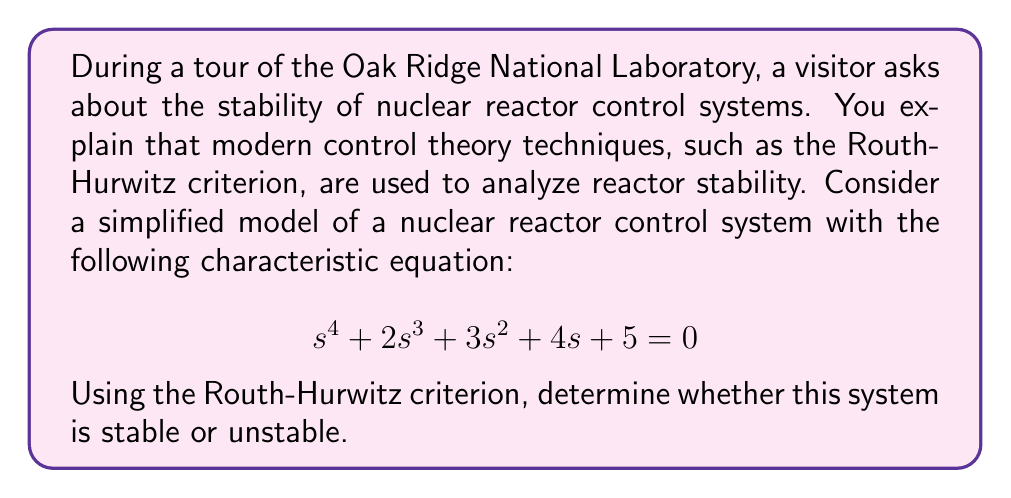Show me your answer to this math problem. To analyze the stability of the system using the Routh-Hurwitz criterion, we need to construct the Routh array and examine the signs of the coefficients in the first column.

Step 1: Construct the Routh array

The Routh array for the given characteristic equation is:

$$\begin{array}{c|cccc}
s^4 & 1 & 3 & 5 \\
s^3 & 2 & 4 & 0 \\
s^2 & b_1 & b_2 & \\
s^1 & c_1 & \\
s^0 & d_1 &
\end{array}$$

Step 2: Calculate the values for $b_1$, $b_2$, $c_1$, and $d_1$

$b_1 = \frac{(2)(3) - (1)(4)}{2} = \frac{6 - 4}{2} = 1$

$b_2 = \frac{(2)(5) - (1)(0)}{2} = \frac{10}{2} = 5$

$c_1 = \frac{(1)(4) - (2)(5)}{1} = 4 - 10 = -6$

$d_1 = 5$ (from the original equation)

Step 3: Complete the Routh array

$$\begin{array}{c|cccc}
s^4 & 1 & 3 & 5 \\
s^3 & 2 & 4 & 0 \\
s^2 & 1 & 5 & \\
s^1 & -6 & \\
s^0 & 5 &
\end{array}$$

Step 4: Analyze the signs in the first column

For a system to be stable, all coefficients in the first column of the Routh array must have the same sign (all positive or all negative). In this case, we see a sign change between $s^1$ and $s^0$ rows.

Therefore, the system is unstable.
Answer: The nuclear reactor control system is unstable, as determined by the Routh-Hurwitz criterion. There is a sign change in the first column of the Routh array, indicating the presence of right-half plane roots in the characteristic equation. 